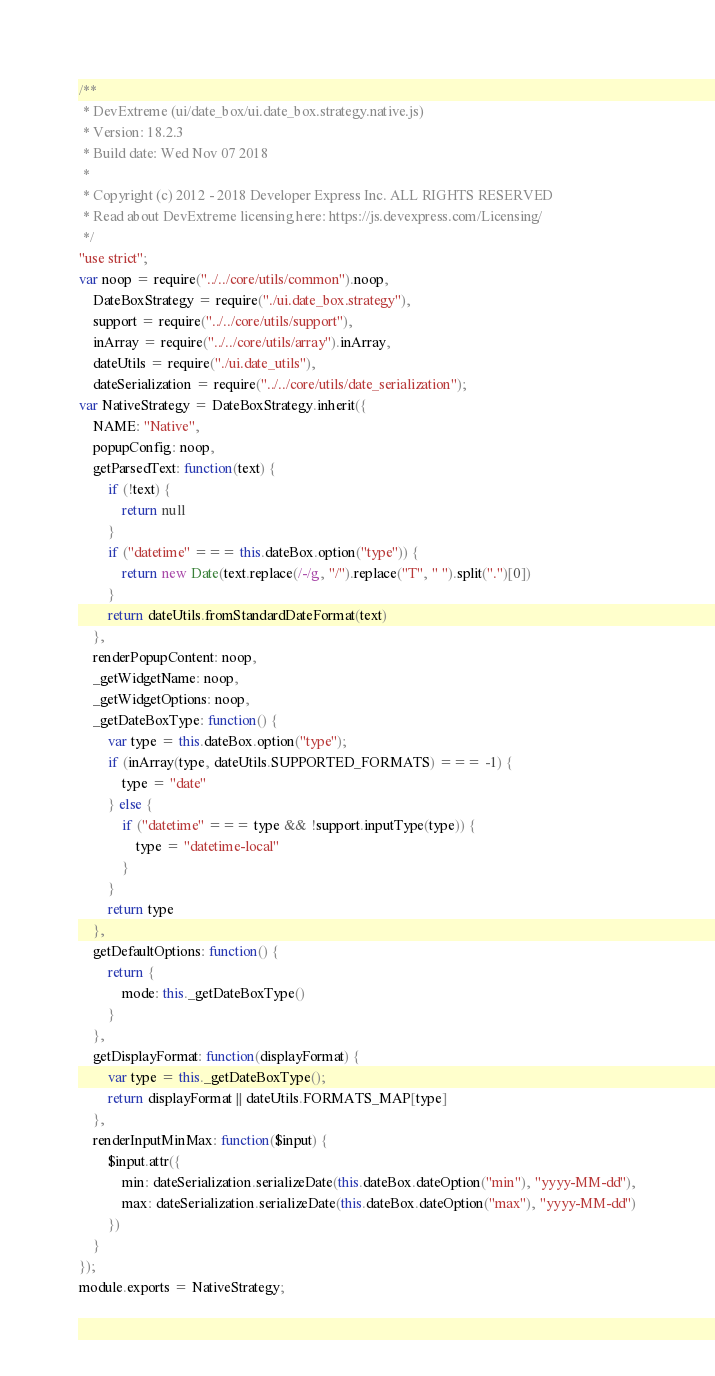<code> <loc_0><loc_0><loc_500><loc_500><_JavaScript_>/**
 * DevExtreme (ui/date_box/ui.date_box.strategy.native.js)
 * Version: 18.2.3
 * Build date: Wed Nov 07 2018
 *
 * Copyright (c) 2012 - 2018 Developer Express Inc. ALL RIGHTS RESERVED
 * Read about DevExtreme licensing here: https://js.devexpress.com/Licensing/
 */
"use strict";
var noop = require("../../core/utils/common").noop,
    DateBoxStrategy = require("./ui.date_box.strategy"),
    support = require("../../core/utils/support"),
    inArray = require("../../core/utils/array").inArray,
    dateUtils = require("./ui.date_utils"),
    dateSerialization = require("../../core/utils/date_serialization");
var NativeStrategy = DateBoxStrategy.inherit({
    NAME: "Native",
    popupConfig: noop,
    getParsedText: function(text) {
        if (!text) {
            return null
        }
        if ("datetime" === this.dateBox.option("type")) {
            return new Date(text.replace(/-/g, "/").replace("T", " ").split(".")[0])
        }
        return dateUtils.fromStandardDateFormat(text)
    },
    renderPopupContent: noop,
    _getWidgetName: noop,
    _getWidgetOptions: noop,
    _getDateBoxType: function() {
        var type = this.dateBox.option("type");
        if (inArray(type, dateUtils.SUPPORTED_FORMATS) === -1) {
            type = "date"
        } else {
            if ("datetime" === type && !support.inputType(type)) {
                type = "datetime-local"
            }
        }
        return type
    },
    getDefaultOptions: function() {
        return {
            mode: this._getDateBoxType()
        }
    },
    getDisplayFormat: function(displayFormat) {
        var type = this._getDateBoxType();
        return displayFormat || dateUtils.FORMATS_MAP[type]
    },
    renderInputMinMax: function($input) {
        $input.attr({
            min: dateSerialization.serializeDate(this.dateBox.dateOption("min"), "yyyy-MM-dd"),
            max: dateSerialization.serializeDate(this.dateBox.dateOption("max"), "yyyy-MM-dd")
        })
    }
});
module.exports = NativeStrategy;
</code> 